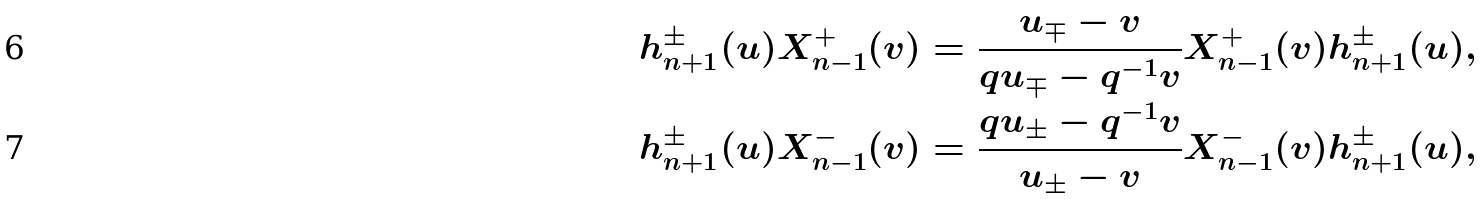Convert formula to latex. <formula><loc_0><loc_0><loc_500><loc_500>h _ { n + 1 } ^ { \pm } ( u ) X _ { n - 1 } ^ { + } ( v ) = \frac { u _ { \mp } - v } { q u _ { \mp } - q ^ { - 1 } v } X _ { n - 1 } ^ { + } ( v ) h _ { n + 1 } ^ { \pm } ( u ) , \\ h _ { n + 1 } ^ { \pm } ( u ) X _ { n - 1 } ^ { - } ( v ) = \frac { q u _ { \pm } - q ^ { - 1 } v } { u _ { \pm } - v } X _ { n - 1 } ^ { - } ( v ) h _ { n + 1 } ^ { \pm } ( u ) ,</formula> 